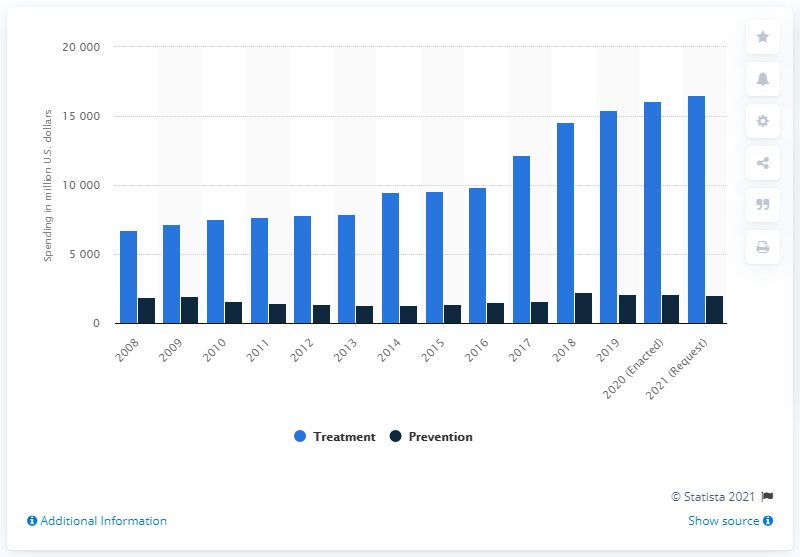Highlight a few significant elements in this photo. In the fiscal year 2019, a total of $213.59 million was spent on drug treatment and prevention in the United States. 